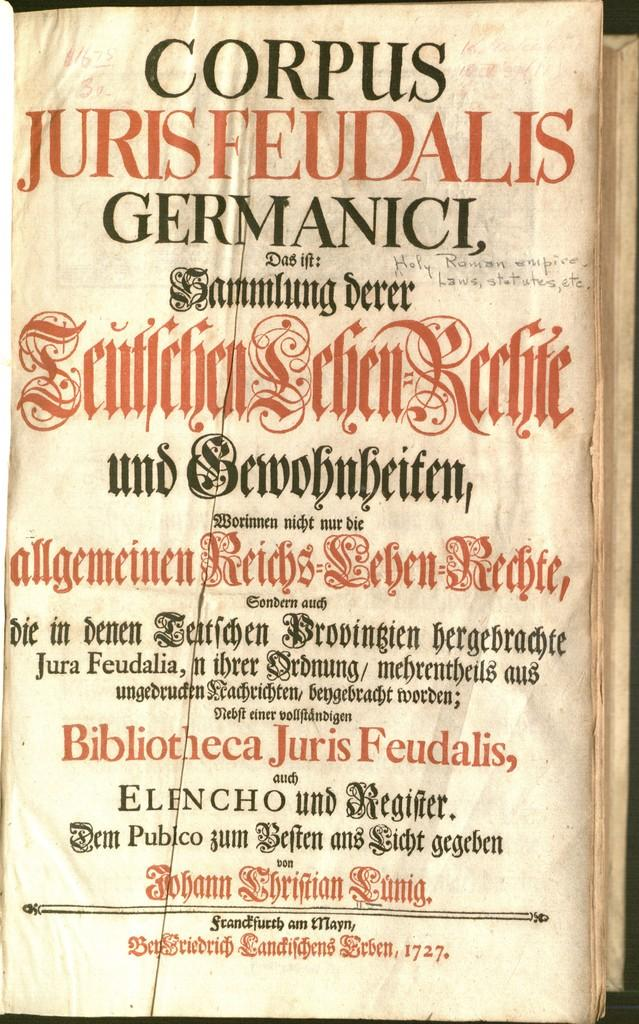<image>
Offer a succinct explanation of the picture presented. The book is old and  called Corpus Jurisfeudalis Germanici. 